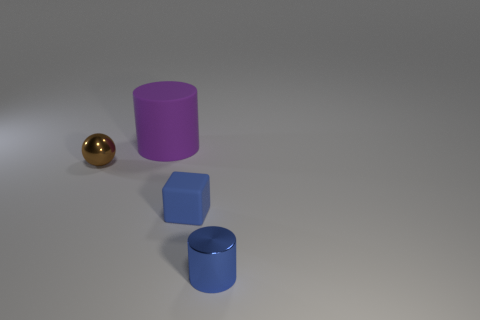How many cylinders are either gray things or big rubber objects?
Make the answer very short. 1. The object that is both on the right side of the tiny metallic sphere and behind the blue rubber block is made of what material?
Keep it short and to the point. Rubber. How many things are behind the tiny matte block?
Give a very brief answer. 2. Is the small blue object that is behind the metal cylinder made of the same material as the cylinder behind the blue shiny object?
Ensure brevity in your answer.  Yes. How many things are blue matte cubes behind the blue metallic cylinder or cyan matte spheres?
Keep it short and to the point. 1. Are there fewer big purple rubber cylinders in front of the metallic ball than small things behind the metallic cylinder?
Provide a succinct answer. Yes. What number of other things are there of the same size as the brown metallic sphere?
Make the answer very short. 2. Are the blue block and the cylinder that is in front of the big purple thing made of the same material?
Your answer should be very brief. No. How many things are tiny shiny objects that are on the right side of the brown object or things behind the blue cylinder?
Ensure brevity in your answer.  4. The matte cube is what color?
Ensure brevity in your answer.  Blue. 